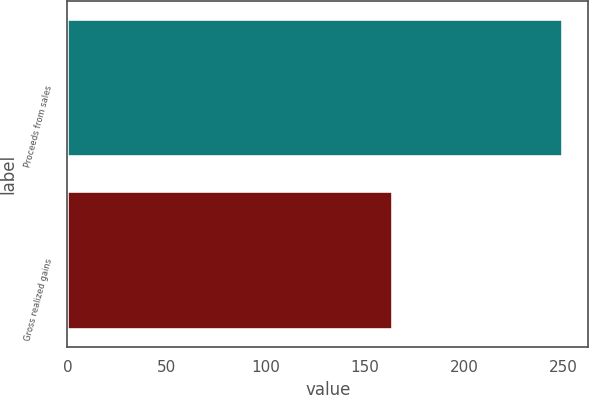<chart> <loc_0><loc_0><loc_500><loc_500><bar_chart><fcel>Proceeds from sales<fcel>Gross realized gains<nl><fcel>250<fcel>164<nl></chart> 